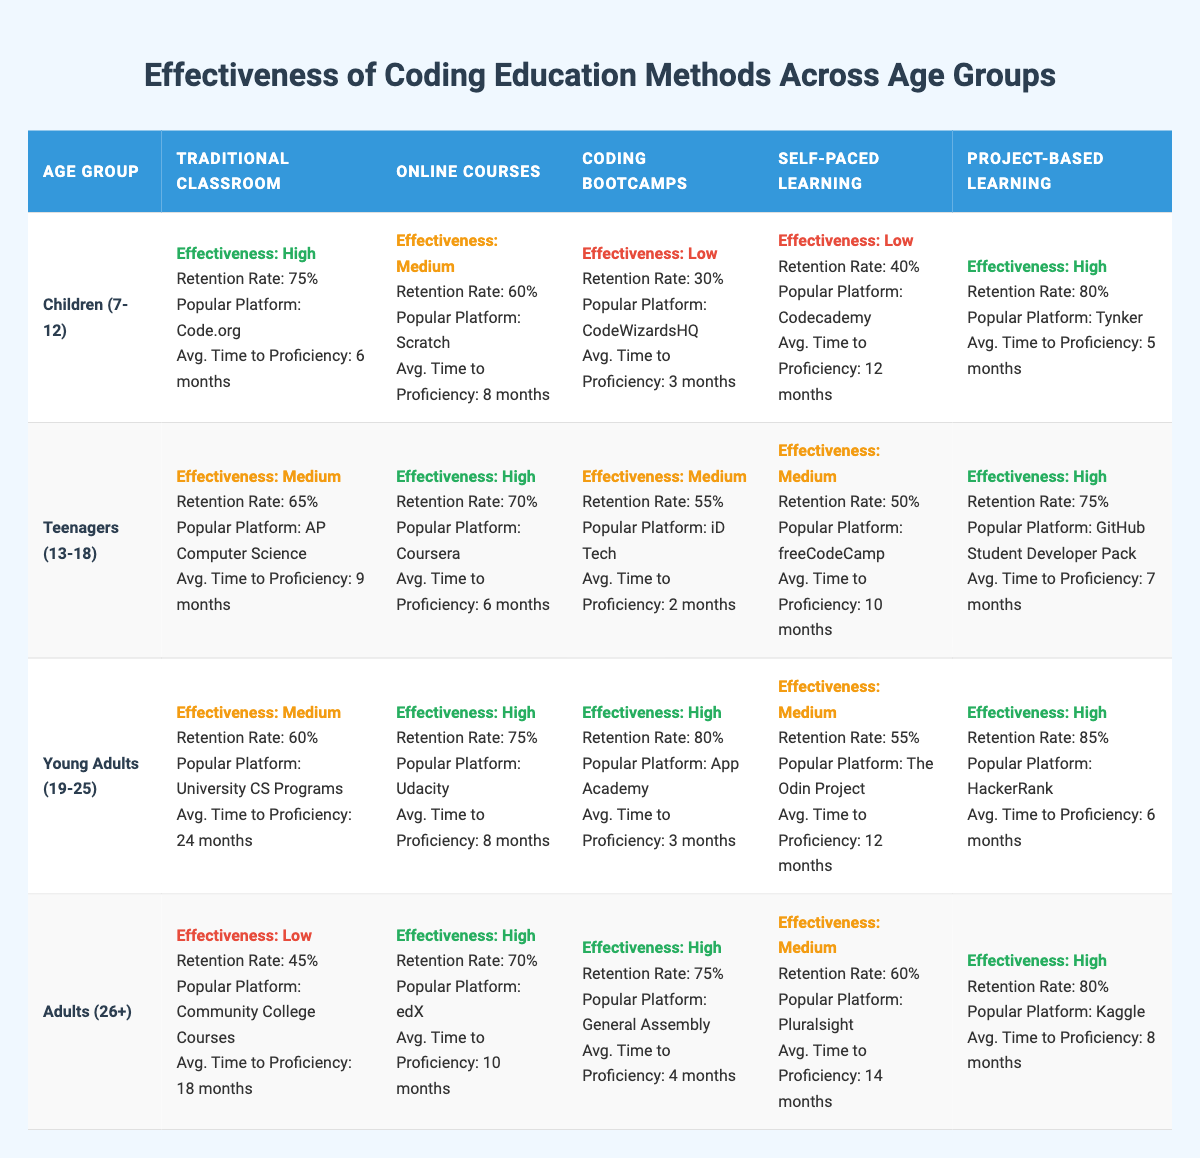What is the average retention rate for children using project-based learning? The retention rate for children using project-based learning is 80%. Since there is only one data point for this category and age group, the average is simply 80%.
Answer: 80% What platform is the most popular for online courses among young adults? The most popular platform for online courses among young adults is Udacity, as stated in the table under the Young Adults (19-25) category.
Answer: Udacity Do coding bootcamps have a higher effectiveness rating compared to traditional classrooms for teenagers? For teenagers, coding bootcamps have a medium effectiveness rating while traditional classrooms also have a medium rating. Since they are equal, coding bootcamps do not have a higher effectiveness rating.
Answer: No What is the difference in average time to proficiency between coding bootcamps and online courses for adults? The average time to proficiency for coding bootcamps for adults is 4 months, and for online courses, it is 10 months. Therefore, the difference in average time to proficiency is 10 - 4 = 6 months.
Answer: 6 months Which age group has the highest overall retention rate for project-based learning? The retention rates for project-based learning are: Children (80%), Teenagers (75%), Young Adults (85%), and Adults (80%). Young Adults have the highest retention rate at 85%.
Answer: Young Adults Which coding education method has the highest effectiveness for children aged 7-12? Among the methods listed for children aged 7-12, both Traditional Classroom and Project-based Learning are marked as having high effectiveness; however, the Project-based Learning also has the highest retention rate of 80% compared to 75% for Traditional Classroom.
Answer: Project-based Learning For which age group is self-paced learning rated as 'Low' in terms of effectiveness? Self-paced learning is rated as 'Low' in effectiveness for two age groups: Children (7-12) and Adults (26+). In both cases, the percentage for retention is 40% and 60% respectively.
Answer: Children and Adults Do adolescents have a higher average retention rate for online courses compared to young adults? The average retention rate for online courses is 70% for teenagers and 75% for young adults. Therefore, young adults have a higher average retention rate.
Answer: No What is the effectiveness of traditional classroom methods for adults aged 26 and over? The effectiveness rating for traditional classroom methods for adults (26+) is low, with a retention rate of 45%.
Answer: Low 